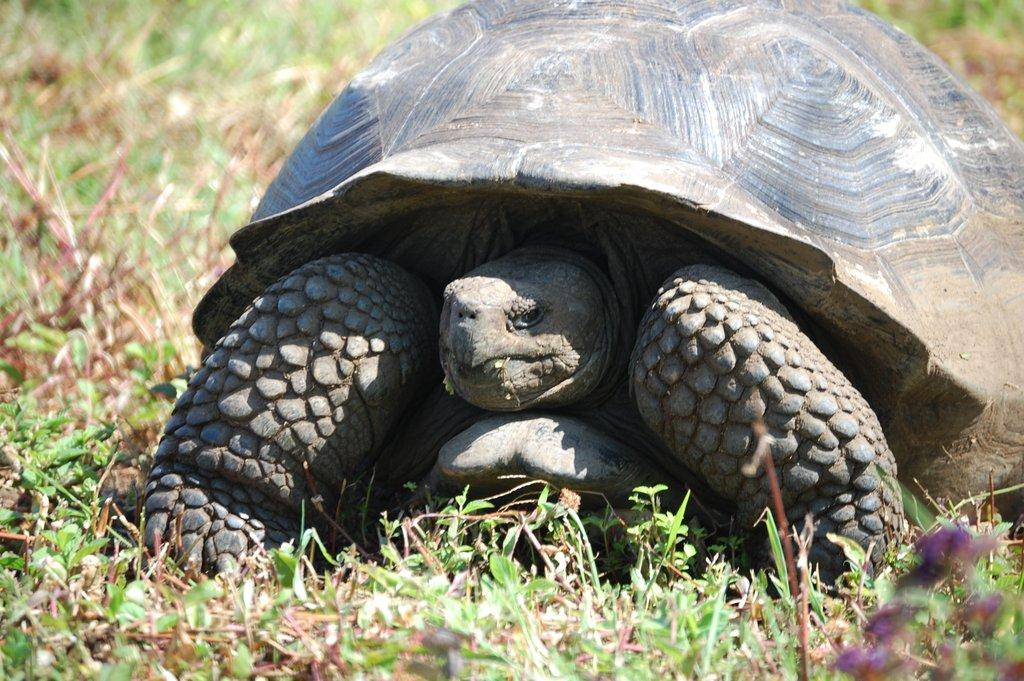What type of animal is present in the image? There is a tortoise in the image. What else can be seen in the image besides the tortoise? There are plants in the image. What type of pump is being used to water the plants in the image? There is no pump present in the image; it only features a tortoise and plants. 